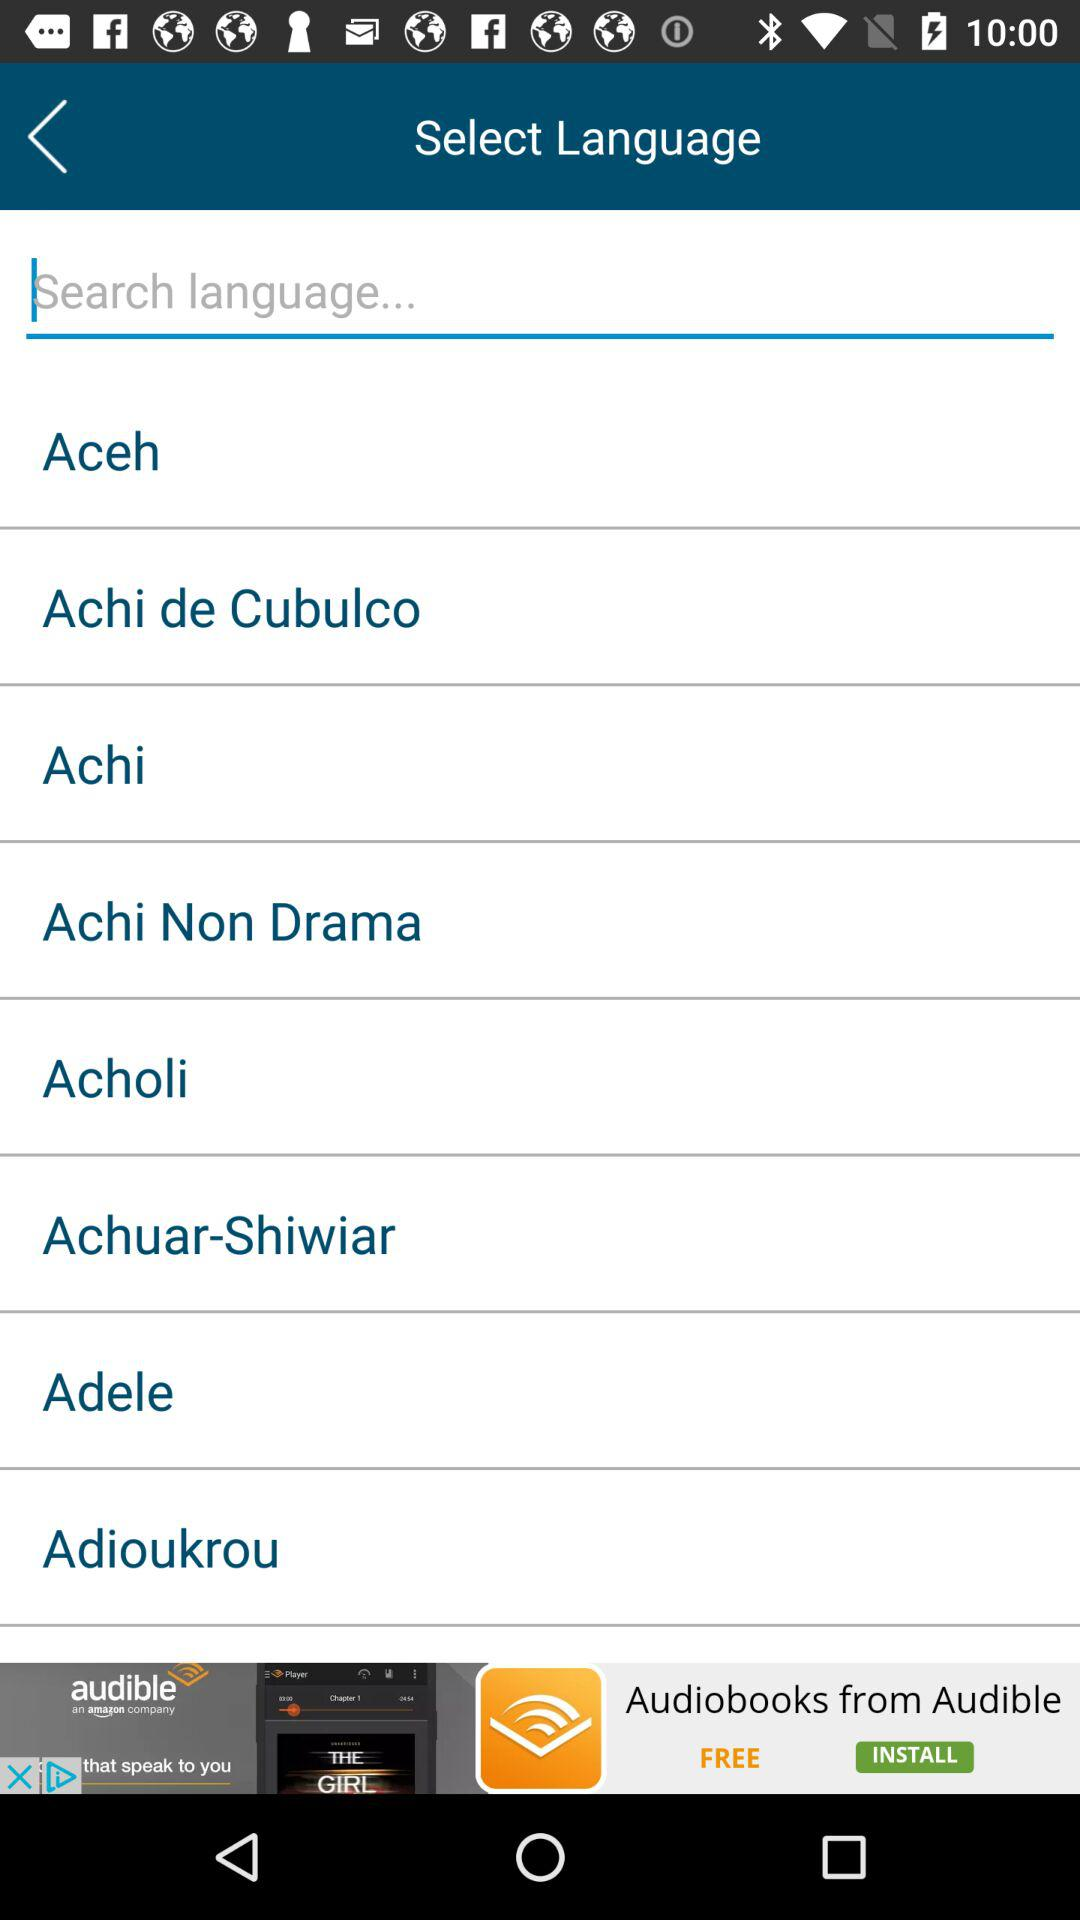Which are the different languages? The different languages are "Aceh", "Achi de Cubulco", "Achi", "Achi Non Drama", "Acholi", "Achuar-Shiwiar", "Adele", and "Adioukrou". 